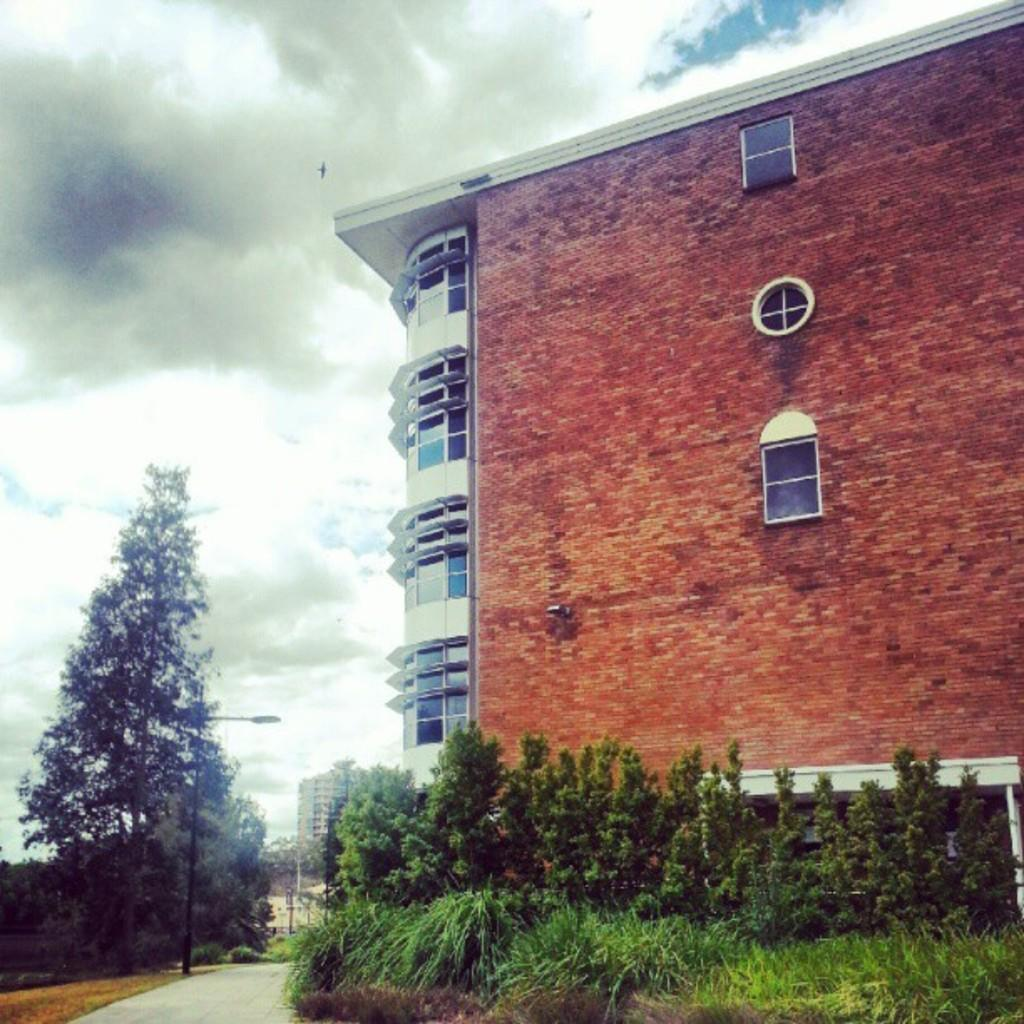What type of structure is present in the image? There is a building in the picture. What feature can be observed on the building? The building has glass windows. What type of vegetation is visible in the image? There are plants and trees in the picture. How would you describe the sky in the image? The sky is clear in the image. Where is the pump located in the image? There is no pump present in the image. What type of celery can be seen growing near the building? There is no celery visible in the image. 